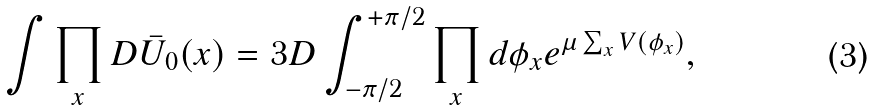Convert formula to latex. <formula><loc_0><loc_0><loc_500><loc_500>\int \prod _ { x } D \bar { U } _ { 0 } ( x ) = 3 D \int _ { - \pi / 2 } ^ { + \pi / 2 } \prod _ { x } d \phi _ { x } e ^ { \mu \sum _ { x } V ( \phi _ { x } ) } ,</formula> 